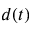<formula> <loc_0><loc_0><loc_500><loc_500>d ( t )</formula> 